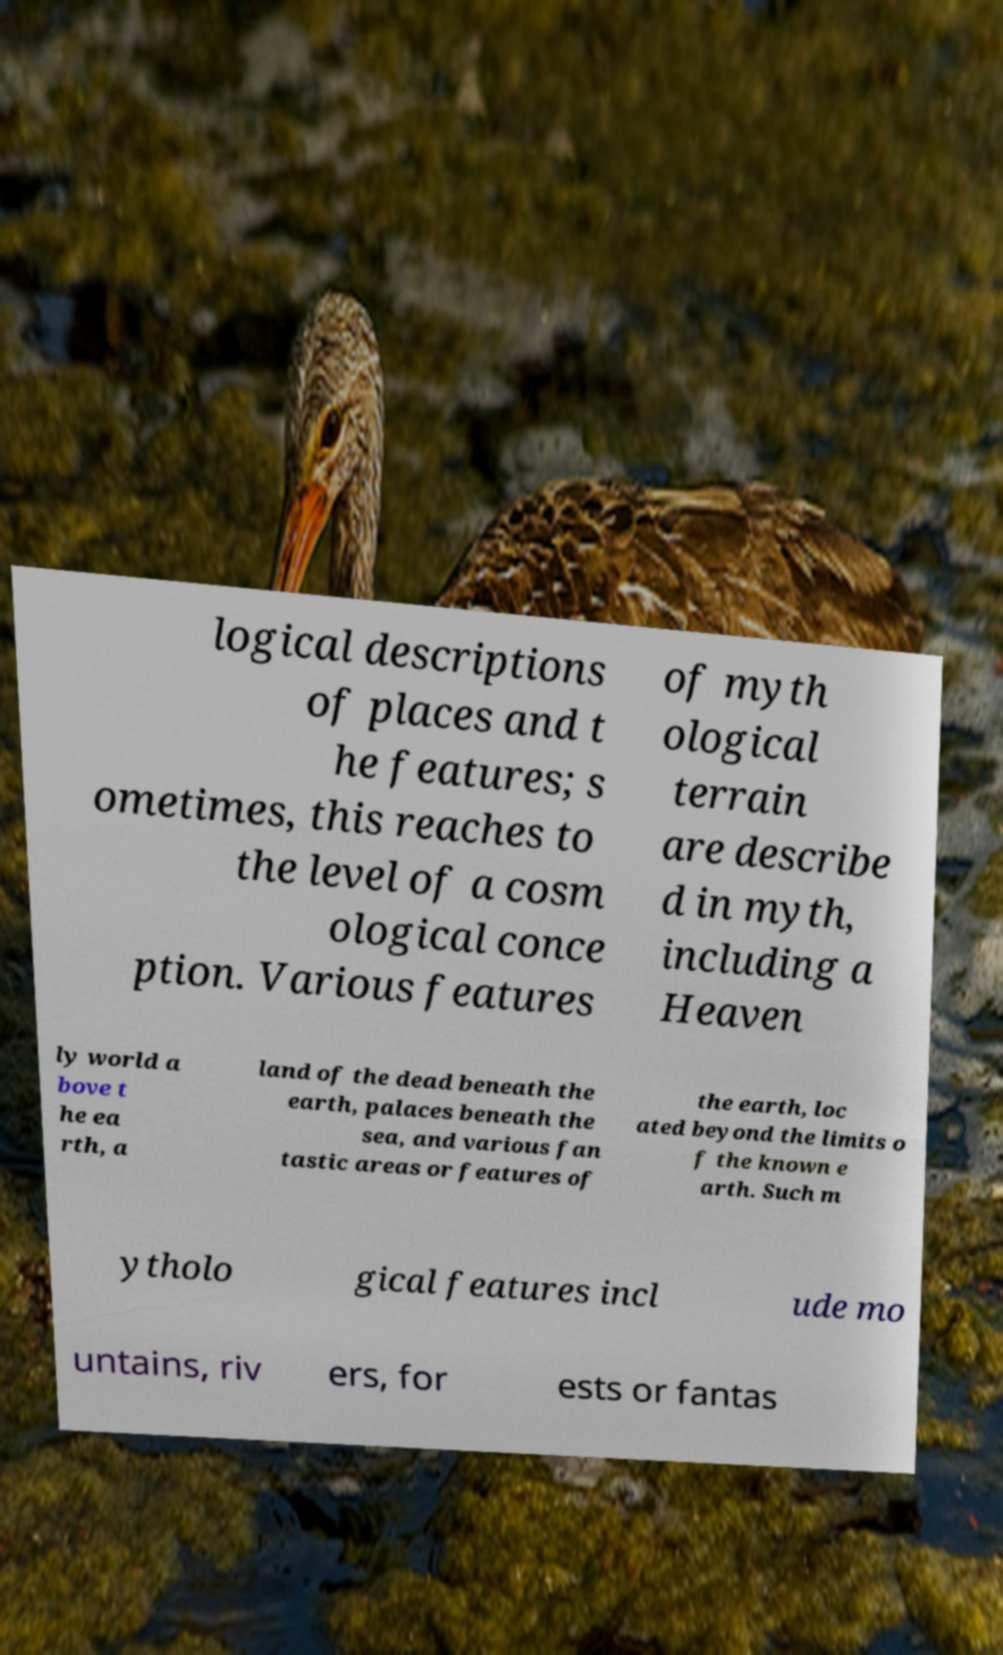Please read and relay the text visible in this image. What does it say? logical descriptions of places and t he features; s ometimes, this reaches to the level of a cosm ological conce ption. Various features of myth ological terrain are describe d in myth, including a Heaven ly world a bove t he ea rth, a land of the dead beneath the earth, palaces beneath the sea, and various fan tastic areas or features of the earth, loc ated beyond the limits o f the known e arth. Such m ytholo gical features incl ude mo untains, riv ers, for ests or fantas 